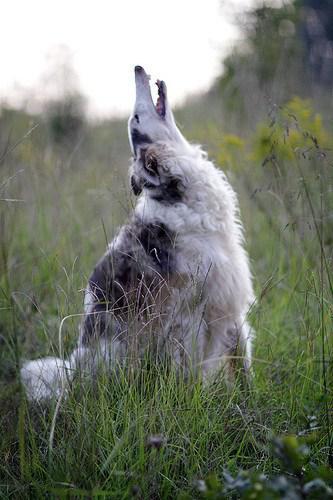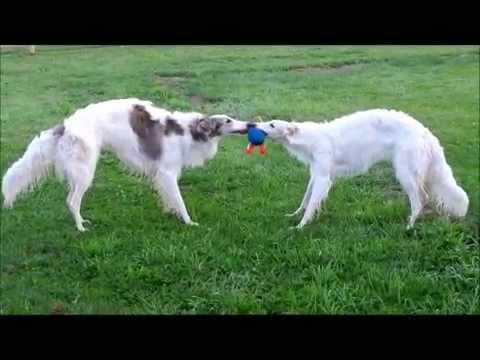The first image is the image on the left, the second image is the image on the right. Assess this claim about the two images: "There is one image of two dogs that are actively playing together outside.". Correct or not? Answer yes or no. Yes. The first image is the image on the left, the second image is the image on the right. Given the left and right images, does the statement "An image shows exactly two hounds." hold true? Answer yes or no. Yes. 